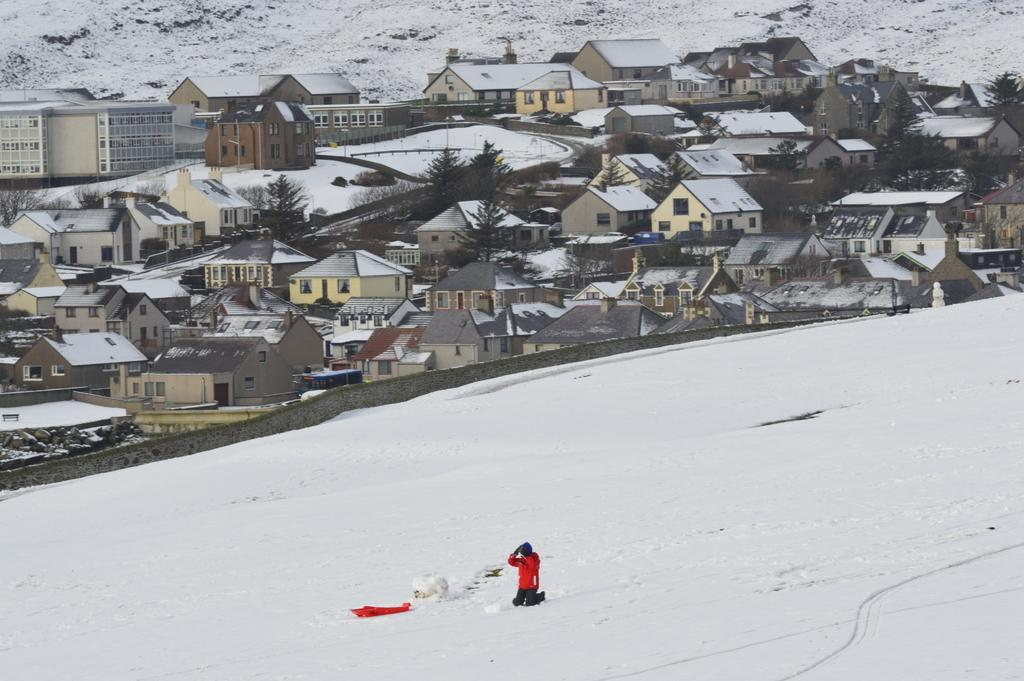Who is present in the image? There is a man in the image. What is the man wearing? The man is wearing a red dress. What is the weather like in the image? There is snow in the image, indicating a cold or wintery environment. What type of structures can be seen in the image? There are houses, trees, and buildings in the image. What type of punishment is being administered to the ship in the image? There is no ship present in the image, so no punishment can be administered to it. What act is the man performing in the image? The image does not depict the man performing any specific act; it only shows him wearing a red dress. 